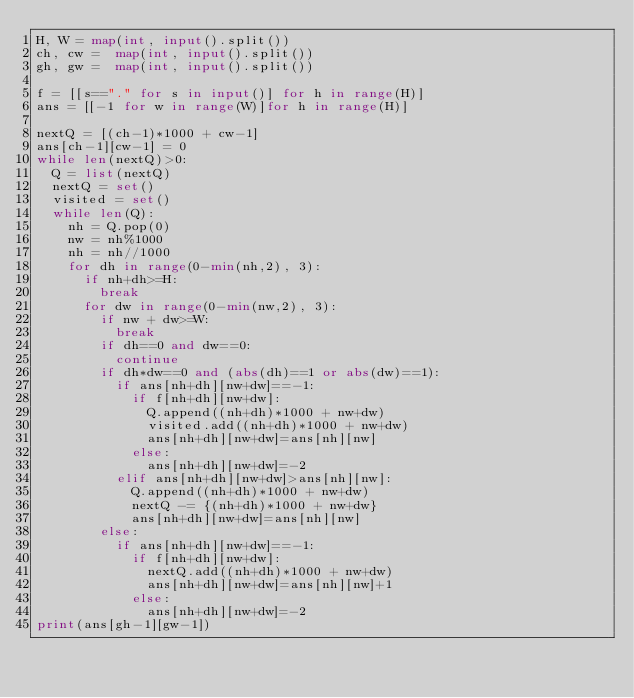<code> <loc_0><loc_0><loc_500><loc_500><_Python_>H, W = map(int, input().split())
ch, cw =  map(int, input().split())
gh, gw =  map(int, input().split())

f = [[s=="." for s in input()] for h in range(H)]
ans = [[-1 for w in range(W)]for h in range(H)]

nextQ = [(ch-1)*1000 + cw-1]
ans[ch-1][cw-1] = 0
while len(nextQ)>0:
  Q = list(nextQ)
  nextQ = set()
  visited = set()
  while len(Q):
    nh = Q.pop(0)
    nw = nh%1000
    nh = nh//1000
    for dh in range(0-min(nh,2), 3):
      if nh+dh>=H:
        break
      for dw in range(0-min(nw,2), 3):
        if nw + dw>=W:
          break
        if dh==0 and dw==0:
          continue
        if dh*dw==0 and (abs(dh)==1 or abs(dw)==1):
          if ans[nh+dh][nw+dw]==-1:
            if f[nh+dh][nw+dw]:
              Q.append((nh+dh)*1000 + nw+dw)
              visited.add((nh+dh)*1000 + nw+dw)
              ans[nh+dh][nw+dw]=ans[nh][nw]
            else:
              ans[nh+dh][nw+dw]=-2
          elif ans[nh+dh][nw+dw]>ans[nh][nw]:
            Q.append((nh+dh)*1000 + nw+dw)
            nextQ -= {(nh+dh)*1000 + nw+dw}
            ans[nh+dh][nw+dw]=ans[nh][nw]
        else:
          if ans[nh+dh][nw+dw]==-1:
            if f[nh+dh][nw+dw]:
              nextQ.add((nh+dh)*1000 + nw+dw)
              ans[nh+dh][nw+dw]=ans[nh][nw]+1
            else:
              ans[nh+dh][nw+dw]=-2
print(ans[gh-1][gw-1])
      
</code> 